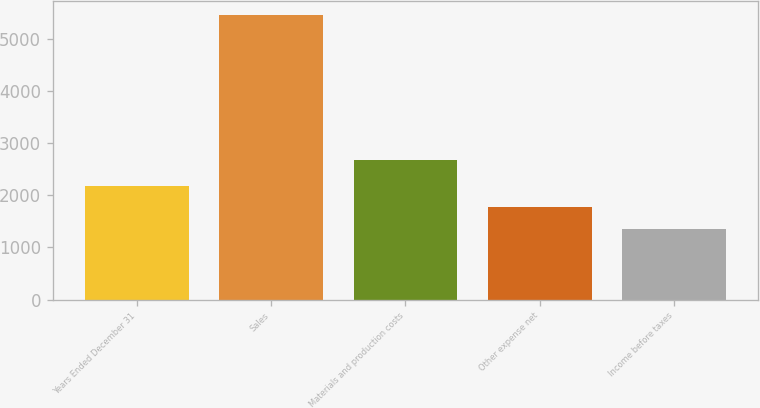Convert chart. <chart><loc_0><loc_0><loc_500><loc_500><bar_chart><fcel>Years Ended December 31<fcel>Sales<fcel>Materials and production costs<fcel>Other expense net<fcel>Income before taxes<nl><fcel>2178<fcel>5450.4<fcel>2682.4<fcel>1768.95<fcel>1359.9<nl></chart> 